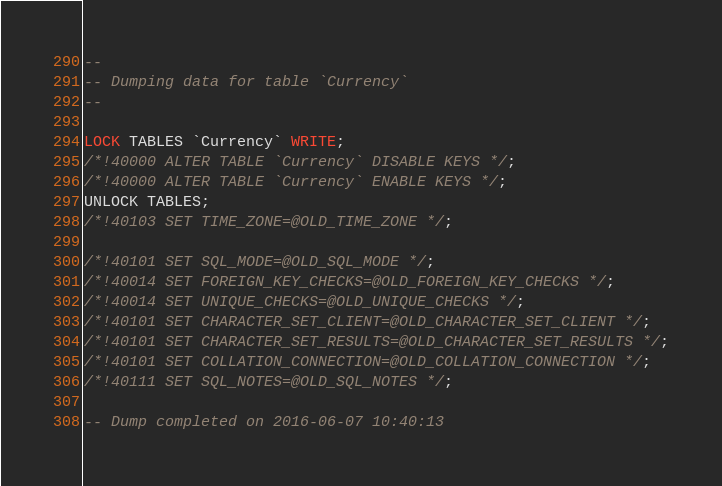<code> <loc_0><loc_0><loc_500><loc_500><_SQL_>
--
-- Dumping data for table `Currency`
--

LOCK TABLES `Currency` WRITE;
/*!40000 ALTER TABLE `Currency` DISABLE KEYS */;
/*!40000 ALTER TABLE `Currency` ENABLE KEYS */;
UNLOCK TABLES;
/*!40103 SET TIME_ZONE=@OLD_TIME_ZONE */;

/*!40101 SET SQL_MODE=@OLD_SQL_MODE */;
/*!40014 SET FOREIGN_KEY_CHECKS=@OLD_FOREIGN_KEY_CHECKS */;
/*!40014 SET UNIQUE_CHECKS=@OLD_UNIQUE_CHECKS */;
/*!40101 SET CHARACTER_SET_CLIENT=@OLD_CHARACTER_SET_CLIENT */;
/*!40101 SET CHARACTER_SET_RESULTS=@OLD_CHARACTER_SET_RESULTS */;
/*!40101 SET COLLATION_CONNECTION=@OLD_COLLATION_CONNECTION */;
/*!40111 SET SQL_NOTES=@OLD_SQL_NOTES */;

-- Dump completed on 2016-06-07 10:40:13
</code> 